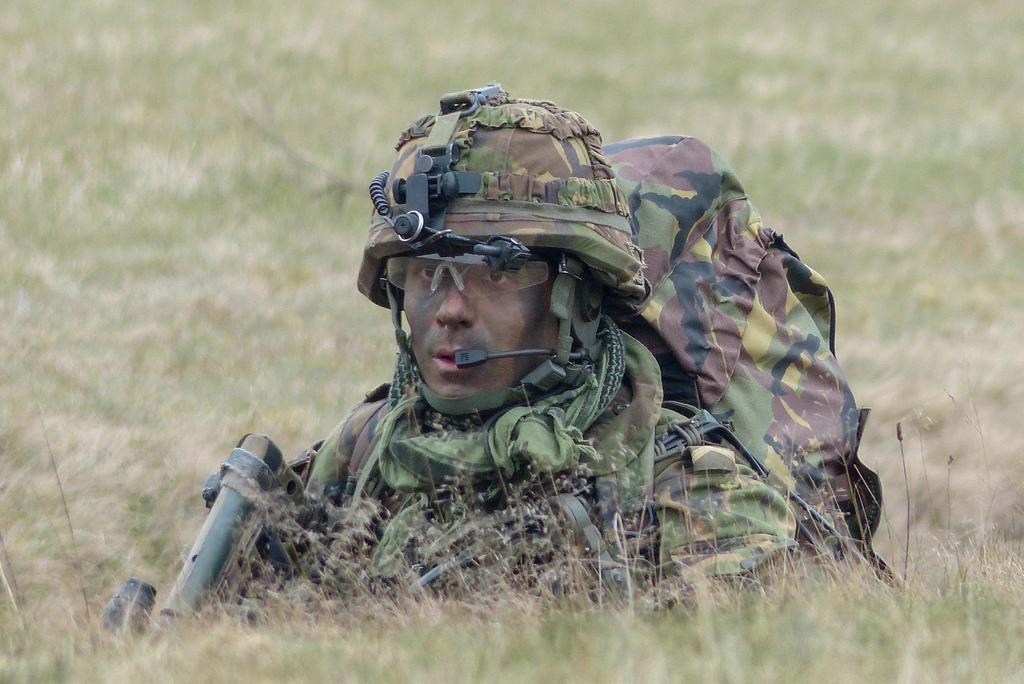In one or two sentences, can you explain what this image depicts? In this image we can see a person with uniform and a helmet on the grass. 